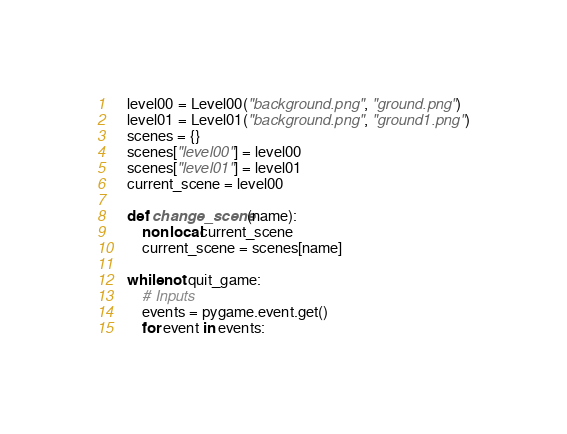Convert code to text. <code><loc_0><loc_0><loc_500><loc_500><_Python_>
    level00 = Level00("background.png", "ground.png")
    level01 = Level01("background.png", "ground1.png")
    scenes = {}
    scenes["level00"] = level00
    scenes["level01"] = level01
    current_scene = level00

    def change_scene(name):
        nonlocal current_scene
        current_scene = scenes[name]

    while not quit_game:
        # Inputs
        events = pygame.event.get()
        for event in events:</code> 